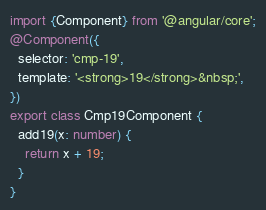<code> <loc_0><loc_0><loc_500><loc_500><_TypeScript_>
import {Component} from '@angular/core';
@Component({
  selector: 'cmp-19',
  template: '<strong>19</strong>&nbsp;',
})
export class Cmp19Component {
  add19(x: number) {
    return x + 19;
  }
}</code> 